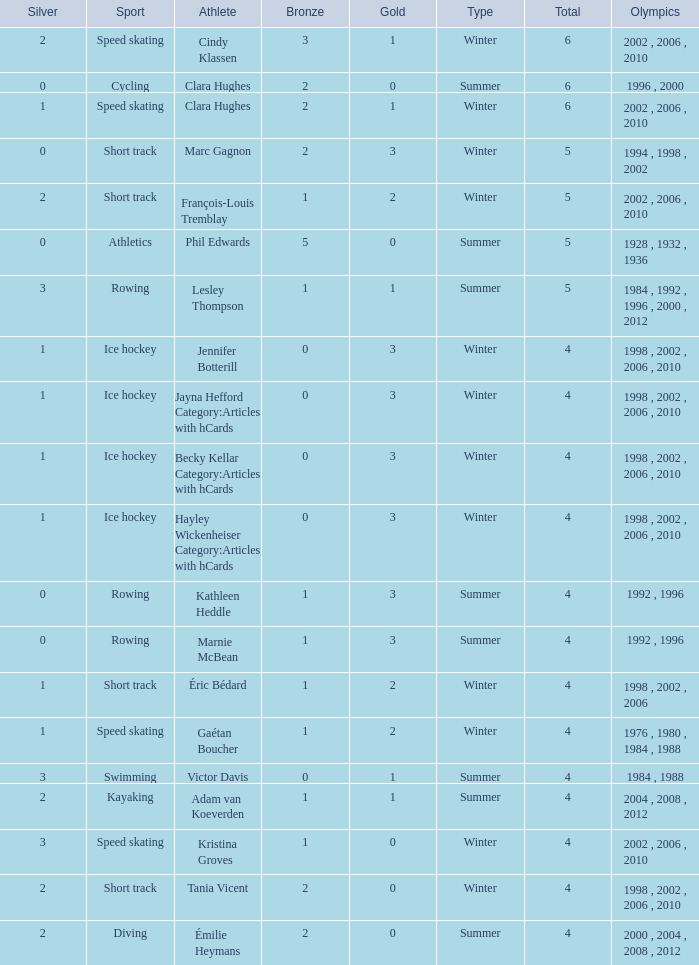What is the highest total medals winter athlete Clara Hughes has? 6.0. 